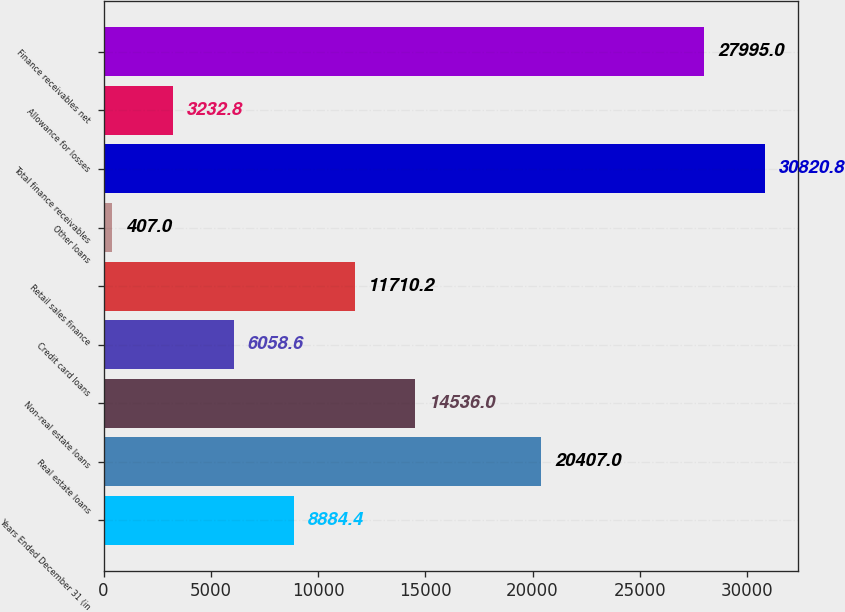Convert chart to OTSL. <chart><loc_0><loc_0><loc_500><loc_500><bar_chart><fcel>Years Ended December 31 (in<fcel>Real estate loans<fcel>Non-real estate loans<fcel>Credit card loans<fcel>Retail sales finance<fcel>Other loans<fcel>Total finance receivables<fcel>Allowance for losses<fcel>Finance receivables net<nl><fcel>8884.4<fcel>20407<fcel>14536<fcel>6058.6<fcel>11710.2<fcel>407<fcel>30820.8<fcel>3232.8<fcel>27995<nl></chart> 